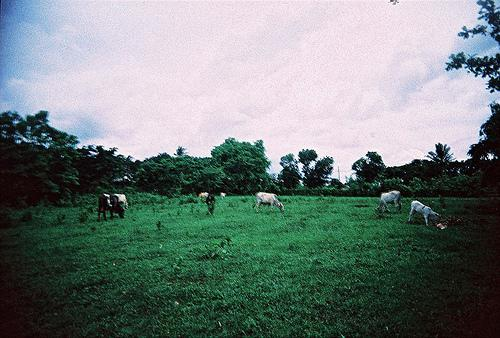Question: why are the cows grazing?
Choices:
A. To create energy.
B. To get food.
C. They are eating.
D. To grow big.
Answer with the letter. Answer: C Question: what animals are pictured?
Choices:
A. Chicken.
B. Pig.
C. Cows.
D. Cat.
Answer with the letter. Answer: C Question: where are the cows?
Choices:
A. In the barn.
B. In the slaughter house.
C. In a field.
D. In the pasture.
Answer with the letter. Answer: C Question: when was the picture taken?
Choices:
A. Morning.
B. Daytime.
C. Noon.
D. Dusk.
Answer with the letter. Answer: B Question: how do the cows get food?
Choices:
A. Delivery.
B. Farmer.
C. Pasture.
D. Grazing.
Answer with the letter. Answer: D 